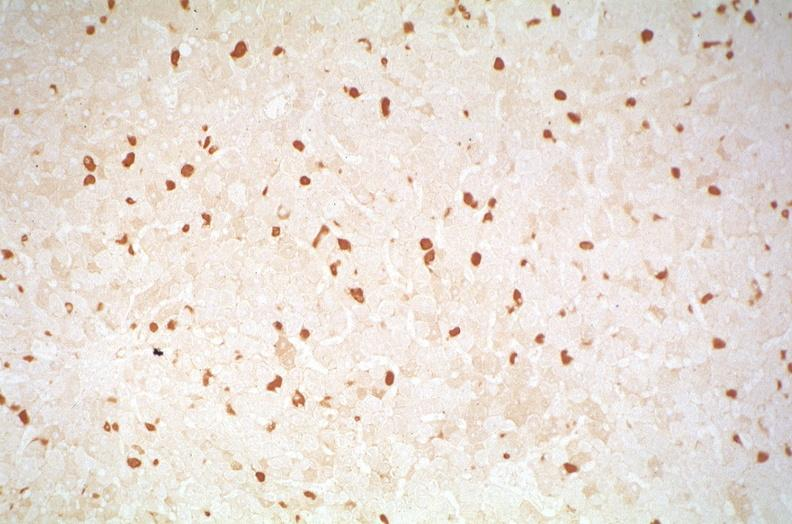what is present?
Answer the question using a single word or phrase. Hepatobiliary 